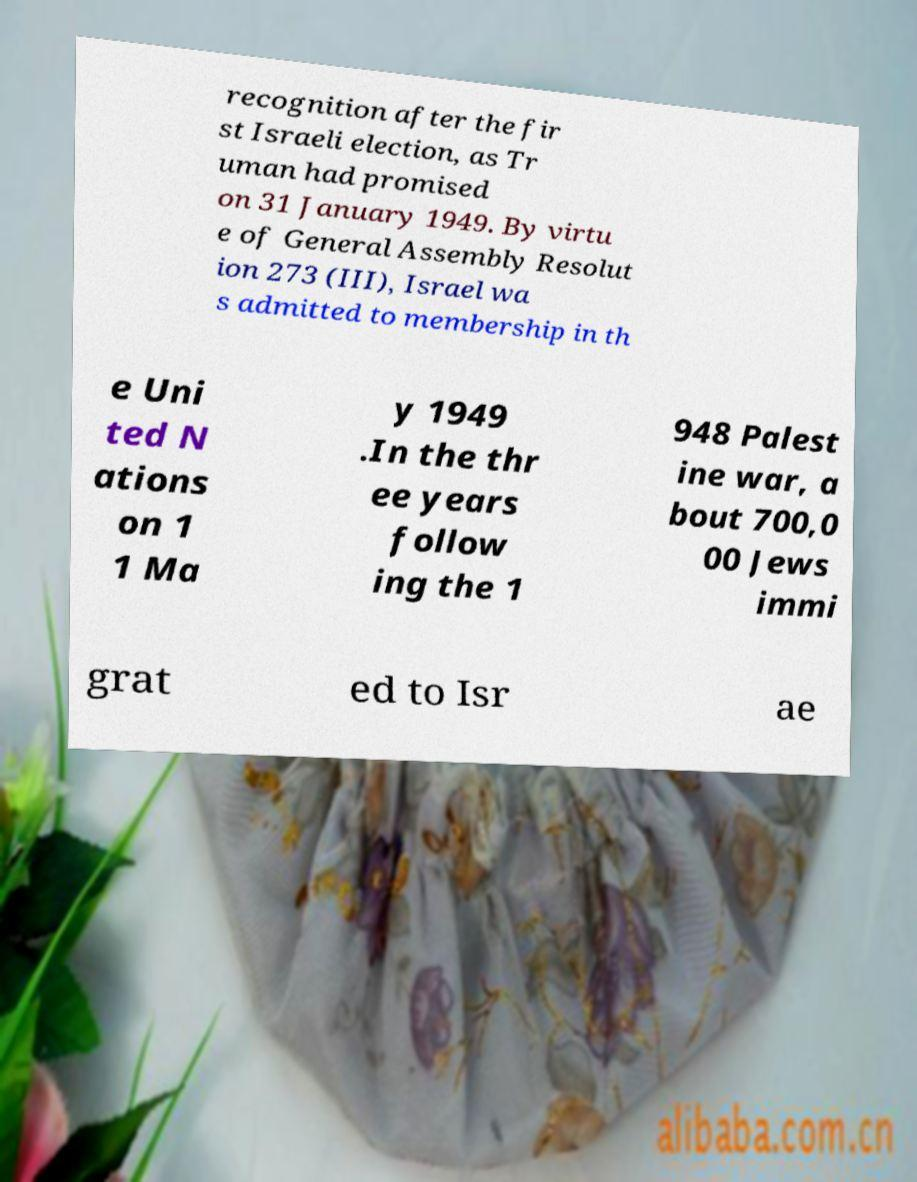Could you extract and type out the text from this image? recognition after the fir st Israeli election, as Tr uman had promised on 31 January 1949. By virtu e of General Assembly Resolut ion 273 (III), Israel wa s admitted to membership in th e Uni ted N ations on 1 1 Ma y 1949 .In the thr ee years follow ing the 1 948 Palest ine war, a bout 700,0 00 Jews immi grat ed to Isr ae 